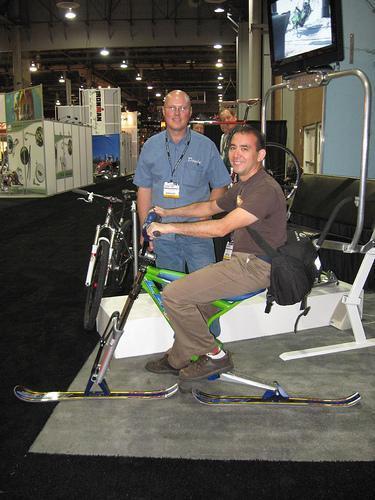How many bicycles are there?
Give a very brief answer. 2. How many people can be seen?
Give a very brief answer. 2. How many horses are there?
Give a very brief answer. 0. 